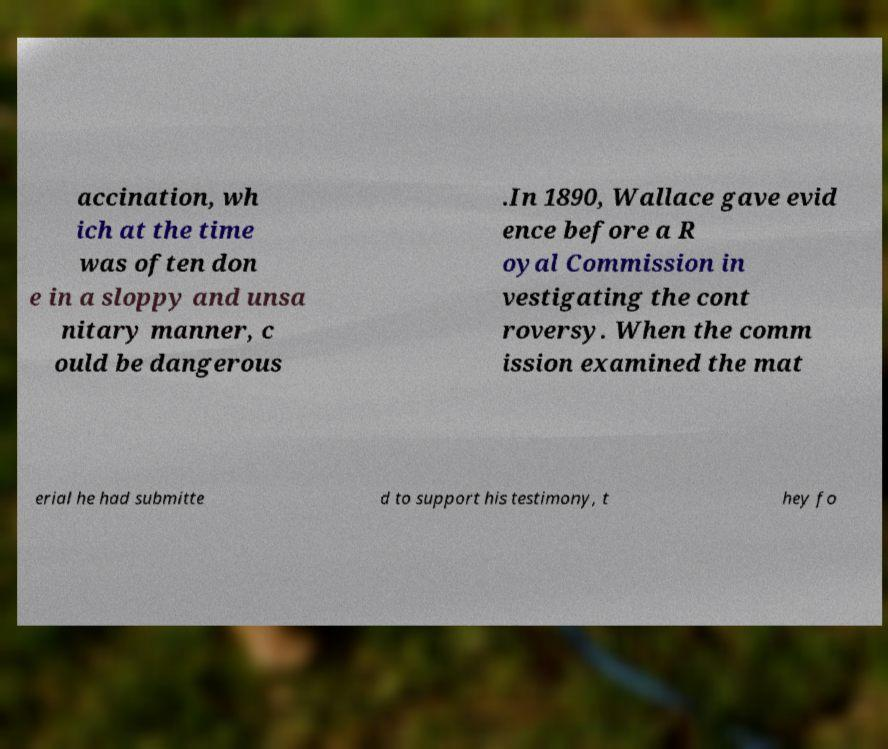Please read and relay the text visible in this image. What does it say? accination, wh ich at the time was often don e in a sloppy and unsa nitary manner, c ould be dangerous .In 1890, Wallace gave evid ence before a R oyal Commission in vestigating the cont roversy. When the comm ission examined the mat erial he had submitte d to support his testimony, t hey fo 